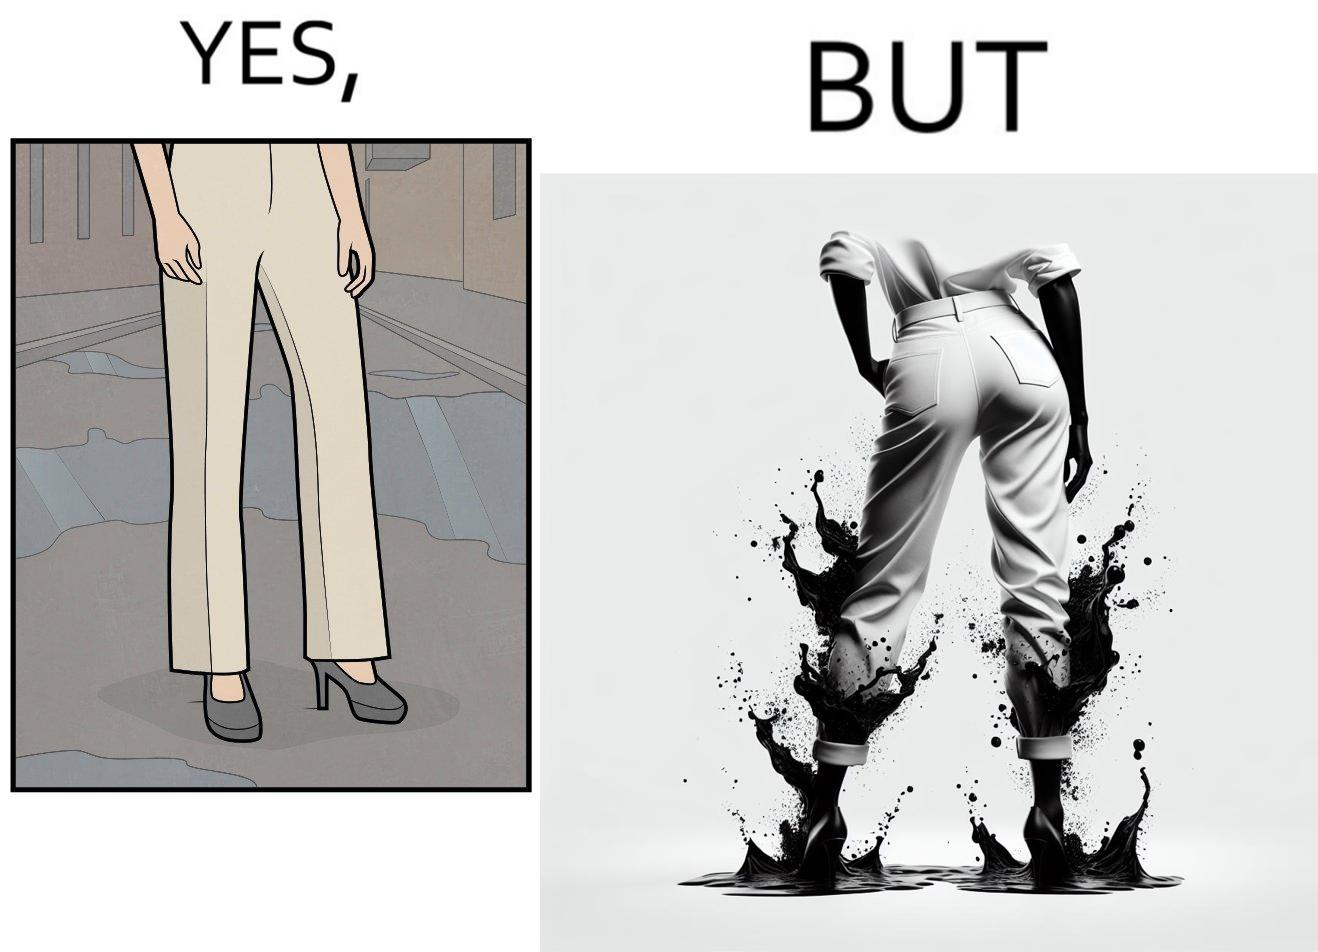Describe what you see in the left and right parts of this image. In the left part of the image: a person wearing white pants and high heels on a road filled with water. In the right part of the image: a person wearing white pants and high heels, but her pants are soaked in water when viewed from the back. 